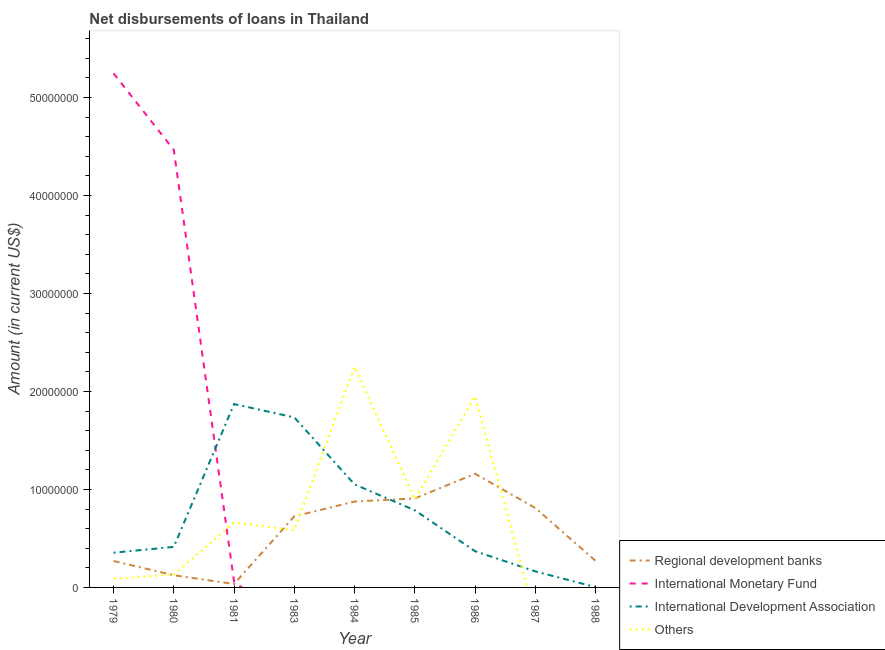Does the line corresponding to amount of loan disimbursed by regional development banks intersect with the line corresponding to amount of loan disimbursed by other organisations?
Give a very brief answer. Yes. What is the amount of loan disimbursed by international monetary fund in 1988?
Your answer should be compact. 0. Across all years, what is the maximum amount of loan disimbursed by international monetary fund?
Give a very brief answer. 5.25e+07. Across all years, what is the minimum amount of loan disimbursed by international development association?
Your response must be concise. 3.50e+04. What is the total amount of loan disimbursed by international monetary fund in the graph?
Your answer should be very brief. 9.77e+07. What is the difference between the amount of loan disimbursed by other organisations in 1979 and that in 1981?
Make the answer very short. -5.74e+06. What is the difference between the amount of loan disimbursed by regional development banks in 1980 and the amount of loan disimbursed by other organisations in 1986?
Offer a very short reply. -1.83e+07. What is the average amount of loan disimbursed by international monetary fund per year?
Your response must be concise. 1.09e+07. In the year 1979, what is the difference between the amount of loan disimbursed by international development association and amount of loan disimbursed by international monetary fund?
Your answer should be very brief. -4.89e+07. What is the ratio of the amount of loan disimbursed by other organisations in 1980 to that in 1983?
Ensure brevity in your answer.  0.23. Is the amount of loan disimbursed by international development association in 1980 less than that in 1981?
Provide a short and direct response. Yes. What is the difference between the highest and the second highest amount of loan disimbursed by regional development banks?
Offer a terse response. 2.52e+06. What is the difference between the highest and the lowest amount of loan disimbursed by international development association?
Your response must be concise. 1.87e+07. In how many years, is the amount of loan disimbursed by regional development banks greater than the average amount of loan disimbursed by regional development banks taken over all years?
Keep it short and to the point. 5. Is the sum of the amount of loan disimbursed by international development association in 1981 and 1986 greater than the maximum amount of loan disimbursed by international monetary fund across all years?
Your answer should be very brief. No. Is it the case that in every year, the sum of the amount of loan disimbursed by international development association and amount of loan disimbursed by international monetary fund is greater than the sum of amount of loan disimbursed by other organisations and amount of loan disimbursed by regional development banks?
Make the answer very short. No. Does the amount of loan disimbursed by other organisations monotonically increase over the years?
Provide a short and direct response. No. Is the amount of loan disimbursed by international monetary fund strictly greater than the amount of loan disimbursed by other organisations over the years?
Your response must be concise. No. Is the amount of loan disimbursed by international monetary fund strictly less than the amount of loan disimbursed by international development association over the years?
Your response must be concise. No. How many lines are there?
Your answer should be compact. 4. How many years are there in the graph?
Give a very brief answer. 9. Are the values on the major ticks of Y-axis written in scientific E-notation?
Your answer should be very brief. No. Where does the legend appear in the graph?
Make the answer very short. Bottom right. How many legend labels are there?
Offer a terse response. 4. How are the legend labels stacked?
Your answer should be very brief. Vertical. What is the title of the graph?
Offer a terse response. Net disbursements of loans in Thailand. What is the label or title of the X-axis?
Your response must be concise. Year. What is the Amount (in current US$) in Regional development banks in 1979?
Provide a short and direct response. 2.70e+06. What is the Amount (in current US$) of International Monetary Fund in 1979?
Give a very brief answer. 5.25e+07. What is the Amount (in current US$) of International Development Association in 1979?
Give a very brief answer. 3.54e+06. What is the Amount (in current US$) in Others in 1979?
Offer a very short reply. 8.80e+05. What is the Amount (in current US$) of Regional development banks in 1980?
Your response must be concise. 1.24e+06. What is the Amount (in current US$) of International Monetary Fund in 1980?
Offer a very short reply. 4.46e+07. What is the Amount (in current US$) in International Development Association in 1980?
Ensure brevity in your answer.  4.14e+06. What is the Amount (in current US$) of Others in 1980?
Provide a succinct answer. 1.32e+06. What is the Amount (in current US$) in Regional development banks in 1981?
Your answer should be compact. 3.49e+05. What is the Amount (in current US$) of International Monetary Fund in 1981?
Offer a terse response. 5.97e+05. What is the Amount (in current US$) in International Development Association in 1981?
Offer a very short reply. 1.87e+07. What is the Amount (in current US$) in Others in 1981?
Ensure brevity in your answer.  6.62e+06. What is the Amount (in current US$) in Regional development banks in 1983?
Provide a short and direct response. 7.25e+06. What is the Amount (in current US$) of International Development Association in 1983?
Give a very brief answer. 1.73e+07. What is the Amount (in current US$) of Others in 1983?
Give a very brief answer. 5.84e+06. What is the Amount (in current US$) of Regional development banks in 1984?
Your answer should be very brief. 8.76e+06. What is the Amount (in current US$) in International Monetary Fund in 1984?
Your answer should be compact. 0. What is the Amount (in current US$) of International Development Association in 1984?
Make the answer very short. 1.05e+07. What is the Amount (in current US$) in Others in 1984?
Keep it short and to the point. 2.25e+07. What is the Amount (in current US$) in Regional development banks in 1985?
Ensure brevity in your answer.  9.08e+06. What is the Amount (in current US$) in International Development Association in 1985?
Make the answer very short. 7.87e+06. What is the Amount (in current US$) of Others in 1985?
Your answer should be very brief. 8.98e+06. What is the Amount (in current US$) of Regional development banks in 1986?
Offer a very short reply. 1.16e+07. What is the Amount (in current US$) in International Development Association in 1986?
Your answer should be compact. 3.70e+06. What is the Amount (in current US$) of Others in 1986?
Your response must be concise. 1.95e+07. What is the Amount (in current US$) in Regional development banks in 1987?
Make the answer very short. 8.10e+06. What is the Amount (in current US$) in International Development Association in 1987?
Make the answer very short. 1.64e+06. What is the Amount (in current US$) of Others in 1987?
Make the answer very short. 0. What is the Amount (in current US$) of Regional development banks in 1988?
Provide a succinct answer. 2.71e+06. What is the Amount (in current US$) in International Development Association in 1988?
Your response must be concise. 3.50e+04. Across all years, what is the maximum Amount (in current US$) in Regional development banks?
Give a very brief answer. 1.16e+07. Across all years, what is the maximum Amount (in current US$) in International Monetary Fund?
Offer a terse response. 5.25e+07. Across all years, what is the maximum Amount (in current US$) of International Development Association?
Offer a terse response. 1.87e+07. Across all years, what is the maximum Amount (in current US$) in Others?
Give a very brief answer. 2.25e+07. Across all years, what is the minimum Amount (in current US$) in Regional development banks?
Offer a terse response. 3.49e+05. Across all years, what is the minimum Amount (in current US$) in International Monetary Fund?
Provide a succinct answer. 0. Across all years, what is the minimum Amount (in current US$) of International Development Association?
Give a very brief answer. 3.50e+04. What is the total Amount (in current US$) in Regional development banks in the graph?
Offer a very short reply. 5.18e+07. What is the total Amount (in current US$) in International Monetary Fund in the graph?
Your answer should be compact. 9.77e+07. What is the total Amount (in current US$) of International Development Association in the graph?
Give a very brief answer. 6.75e+07. What is the total Amount (in current US$) in Others in the graph?
Offer a very short reply. 6.57e+07. What is the difference between the Amount (in current US$) in Regional development banks in 1979 and that in 1980?
Provide a succinct answer. 1.46e+06. What is the difference between the Amount (in current US$) of International Monetary Fund in 1979 and that in 1980?
Your answer should be very brief. 7.81e+06. What is the difference between the Amount (in current US$) in International Development Association in 1979 and that in 1980?
Offer a terse response. -5.97e+05. What is the difference between the Amount (in current US$) in Others in 1979 and that in 1980?
Offer a terse response. -4.36e+05. What is the difference between the Amount (in current US$) of Regional development banks in 1979 and that in 1981?
Offer a terse response. 2.35e+06. What is the difference between the Amount (in current US$) in International Monetary Fund in 1979 and that in 1981?
Your response must be concise. 5.19e+07. What is the difference between the Amount (in current US$) of International Development Association in 1979 and that in 1981?
Ensure brevity in your answer.  -1.52e+07. What is the difference between the Amount (in current US$) in Others in 1979 and that in 1981?
Give a very brief answer. -5.74e+06. What is the difference between the Amount (in current US$) in Regional development banks in 1979 and that in 1983?
Make the answer very short. -4.56e+06. What is the difference between the Amount (in current US$) in International Development Association in 1979 and that in 1983?
Make the answer very short. -1.38e+07. What is the difference between the Amount (in current US$) of Others in 1979 and that in 1983?
Offer a very short reply. -4.96e+06. What is the difference between the Amount (in current US$) of Regional development banks in 1979 and that in 1984?
Offer a terse response. -6.07e+06. What is the difference between the Amount (in current US$) in International Development Association in 1979 and that in 1984?
Give a very brief answer. -6.97e+06. What is the difference between the Amount (in current US$) of Others in 1979 and that in 1984?
Your answer should be very brief. -2.16e+07. What is the difference between the Amount (in current US$) of Regional development banks in 1979 and that in 1985?
Give a very brief answer. -6.38e+06. What is the difference between the Amount (in current US$) in International Development Association in 1979 and that in 1985?
Your answer should be very brief. -4.33e+06. What is the difference between the Amount (in current US$) in Others in 1979 and that in 1985?
Make the answer very short. -8.10e+06. What is the difference between the Amount (in current US$) in Regional development banks in 1979 and that in 1986?
Your answer should be compact. -8.90e+06. What is the difference between the Amount (in current US$) of International Development Association in 1979 and that in 1986?
Ensure brevity in your answer.  -1.55e+05. What is the difference between the Amount (in current US$) of Others in 1979 and that in 1986?
Your response must be concise. -1.86e+07. What is the difference between the Amount (in current US$) of Regional development banks in 1979 and that in 1987?
Give a very brief answer. -5.41e+06. What is the difference between the Amount (in current US$) of International Development Association in 1979 and that in 1987?
Keep it short and to the point. 1.90e+06. What is the difference between the Amount (in current US$) of Regional development banks in 1979 and that in 1988?
Your answer should be very brief. -1.30e+04. What is the difference between the Amount (in current US$) in International Development Association in 1979 and that in 1988?
Your answer should be compact. 3.51e+06. What is the difference between the Amount (in current US$) in Regional development banks in 1980 and that in 1981?
Keep it short and to the point. 8.93e+05. What is the difference between the Amount (in current US$) in International Monetary Fund in 1980 and that in 1981?
Provide a succinct answer. 4.41e+07. What is the difference between the Amount (in current US$) of International Development Association in 1980 and that in 1981?
Offer a very short reply. -1.46e+07. What is the difference between the Amount (in current US$) in Others in 1980 and that in 1981?
Provide a short and direct response. -5.31e+06. What is the difference between the Amount (in current US$) of Regional development banks in 1980 and that in 1983?
Provide a succinct answer. -6.01e+06. What is the difference between the Amount (in current US$) in International Development Association in 1980 and that in 1983?
Give a very brief answer. -1.32e+07. What is the difference between the Amount (in current US$) in Others in 1980 and that in 1983?
Ensure brevity in your answer.  -4.53e+06. What is the difference between the Amount (in current US$) of Regional development banks in 1980 and that in 1984?
Provide a short and direct response. -7.52e+06. What is the difference between the Amount (in current US$) of International Development Association in 1980 and that in 1984?
Ensure brevity in your answer.  -6.37e+06. What is the difference between the Amount (in current US$) of Others in 1980 and that in 1984?
Keep it short and to the point. -2.12e+07. What is the difference between the Amount (in current US$) of Regional development banks in 1980 and that in 1985?
Your answer should be compact. -7.84e+06. What is the difference between the Amount (in current US$) of International Development Association in 1980 and that in 1985?
Provide a succinct answer. -3.74e+06. What is the difference between the Amount (in current US$) in Others in 1980 and that in 1985?
Offer a very short reply. -7.67e+06. What is the difference between the Amount (in current US$) of Regional development banks in 1980 and that in 1986?
Offer a very short reply. -1.04e+07. What is the difference between the Amount (in current US$) of International Development Association in 1980 and that in 1986?
Ensure brevity in your answer.  4.42e+05. What is the difference between the Amount (in current US$) in Others in 1980 and that in 1986?
Your answer should be compact. -1.82e+07. What is the difference between the Amount (in current US$) in Regional development banks in 1980 and that in 1987?
Keep it short and to the point. -6.86e+06. What is the difference between the Amount (in current US$) in International Development Association in 1980 and that in 1987?
Provide a short and direct response. 2.50e+06. What is the difference between the Amount (in current US$) in Regional development banks in 1980 and that in 1988?
Offer a very short reply. -1.47e+06. What is the difference between the Amount (in current US$) in International Development Association in 1980 and that in 1988?
Give a very brief answer. 4.10e+06. What is the difference between the Amount (in current US$) in Regional development banks in 1981 and that in 1983?
Ensure brevity in your answer.  -6.90e+06. What is the difference between the Amount (in current US$) in International Development Association in 1981 and that in 1983?
Keep it short and to the point. 1.37e+06. What is the difference between the Amount (in current US$) in Others in 1981 and that in 1983?
Ensure brevity in your answer.  7.80e+05. What is the difference between the Amount (in current US$) in Regional development banks in 1981 and that in 1984?
Keep it short and to the point. -8.42e+06. What is the difference between the Amount (in current US$) in International Development Association in 1981 and that in 1984?
Offer a terse response. 8.20e+06. What is the difference between the Amount (in current US$) in Others in 1981 and that in 1984?
Your response must be concise. -1.59e+07. What is the difference between the Amount (in current US$) in Regional development banks in 1981 and that in 1985?
Provide a succinct answer. -8.73e+06. What is the difference between the Amount (in current US$) of International Development Association in 1981 and that in 1985?
Provide a succinct answer. 1.08e+07. What is the difference between the Amount (in current US$) in Others in 1981 and that in 1985?
Ensure brevity in your answer.  -2.36e+06. What is the difference between the Amount (in current US$) in Regional development banks in 1981 and that in 1986?
Your answer should be very brief. -1.13e+07. What is the difference between the Amount (in current US$) of International Development Association in 1981 and that in 1986?
Offer a very short reply. 1.50e+07. What is the difference between the Amount (in current US$) in Others in 1981 and that in 1986?
Your answer should be very brief. -1.29e+07. What is the difference between the Amount (in current US$) in Regional development banks in 1981 and that in 1987?
Offer a terse response. -7.76e+06. What is the difference between the Amount (in current US$) in International Development Association in 1981 and that in 1987?
Provide a short and direct response. 1.71e+07. What is the difference between the Amount (in current US$) in Regional development banks in 1981 and that in 1988?
Make the answer very short. -2.36e+06. What is the difference between the Amount (in current US$) in International Development Association in 1981 and that in 1988?
Provide a succinct answer. 1.87e+07. What is the difference between the Amount (in current US$) in Regional development banks in 1983 and that in 1984?
Keep it short and to the point. -1.51e+06. What is the difference between the Amount (in current US$) in International Development Association in 1983 and that in 1984?
Make the answer very short. 6.84e+06. What is the difference between the Amount (in current US$) of Others in 1983 and that in 1984?
Provide a short and direct response. -1.67e+07. What is the difference between the Amount (in current US$) in Regional development banks in 1983 and that in 1985?
Give a very brief answer. -1.83e+06. What is the difference between the Amount (in current US$) in International Development Association in 1983 and that in 1985?
Offer a terse response. 9.48e+06. What is the difference between the Amount (in current US$) of Others in 1983 and that in 1985?
Provide a succinct answer. -3.14e+06. What is the difference between the Amount (in current US$) of Regional development banks in 1983 and that in 1986?
Your response must be concise. -4.35e+06. What is the difference between the Amount (in current US$) of International Development Association in 1983 and that in 1986?
Your answer should be compact. 1.37e+07. What is the difference between the Amount (in current US$) of Others in 1983 and that in 1986?
Keep it short and to the point. -1.37e+07. What is the difference between the Amount (in current US$) in Regional development banks in 1983 and that in 1987?
Provide a succinct answer. -8.52e+05. What is the difference between the Amount (in current US$) of International Development Association in 1983 and that in 1987?
Your response must be concise. 1.57e+07. What is the difference between the Amount (in current US$) of Regional development banks in 1983 and that in 1988?
Offer a terse response. 4.54e+06. What is the difference between the Amount (in current US$) of International Development Association in 1983 and that in 1988?
Your answer should be very brief. 1.73e+07. What is the difference between the Amount (in current US$) in Regional development banks in 1984 and that in 1985?
Give a very brief answer. -3.15e+05. What is the difference between the Amount (in current US$) in International Development Association in 1984 and that in 1985?
Make the answer very short. 2.64e+06. What is the difference between the Amount (in current US$) of Others in 1984 and that in 1985?
Your answer should be very brief. 1.35e+07. What is the difference between the Amount (in current US$) in Regional development banks in 1984 and that in 1986?
Make the answer very short. -2.84e+06. What is the difference between the Amount (in current US$) of International Development Association in 1984 and that in 1986?
Your answer should be very brief. 6.82e+06. What is the difference between the Amount (in current US$) of Others in 1984 and that in 1986?
Provide a short and direct response. 3.02e+06. What is the difference between the Amount (in current US$) in Regional development banks in 1984 and that in 1987?
Make the answer very short. 6.59e+05. What is the difference between the Amount (in current US$) in International Development Association in 1984 and that in 1987?
Offer a very short reply. 8.88e+06. What is the difference between the Amount (in current US$) of Regional development banks in 1984 and that in 1988?
Offer a terse response. 6.05e+06. What is the difference between the Amount (in current US$) in International Development Association in 1984 and that in 1988?
Provide a short and direct response. 1.05e+07. What is the difference between the Amount (in current US$) of Regional development banks in 1985 and that in 1986?
Your answer should be very brief. -2.52e+06. What is the difference between the Amount (in current US$) in International Development Association in 1985 and that in 1986?
Keep it short and to the point. 4.18e+06. What is the difference between the Amount (in current US$) of Others in 1985 and that in 1986?
Make the answer very short. -1.05e+07. What is the difference between the Amount (in current US$) in Regional development banks in 1985 and that in 1987?
Provide a short and direct response. 9.74e+05. What is the difference between the Amount (in current US$) of International Development Association in 1985 and that in 1987?
Your answer should be very brief. 6.24e+06. What is the difference between the Amount (in current US$) of Regional development banks in 1985 and that in 1988?
Ensure brevity in your answer.  6.37e+06. What is the difference between the Amount (in current US$) of International Development Association in 1985 and that in 1988?
Your answer should be compact. 7.84e+06. What is the difference between the Amount (in current US$) of Regional development banks in 1986 and that in 1987?
Offer a terse response. 3.50e+06. What is the difference between the Amount (in current US$) in International Development Association in 1986 and that in 1987?
Give a very brief answer. 2.06e+06. What is the difference between the Amount (in current US$) of Regional development banks in 1986 and that in 1988?
Offer a very short reply. 8.89e+06. What is the difference between the Amount (in current US$) of International Development Association in 1986 and that in 1988?
Your answer should be compact. 3.66e+06. What is the difference between the Amount (in current US$) of Regional development banks in 1987 and that in 1988?
Keep it short and to the point. 5.39e+06. What is the difference between the Amount (in current US$) of International Development Association in 1987 and that in 1988?
Provide a short and direct response. 1.60e+06. What is the difference between the Amount (in current US$) of Regional development banks in 1979 and the Amount (in current US$) of International Monetary Fund in 1980?
Make the answer very short. -4.20e+07. What is the difference between the Amount (in current US$) of Regional development banks in 1979 and the Amount (in current US$) of International Development Association in 1980?
Your answer should be compact. -1.44e+06. What is the difference between the Amount (in current US$) of Regional development banks in 1979 and the Amount (in current US$) of Others in 1980?
Your answer should be compact. 1.38e+06. What is the difference between the Amount (in current US$) in International Monetary Fund in 1979 and the Amount (in current US$) in International Development Association in 1980?
Give a very brief answer. 4.83e+07. What is the difference between the Amount (in current US$) in International Monetary Fund in 1979 and the Amount (in current US$) in Others in 1980?
Provide a succinct answer. 5.11e+07. What is the difference between the Amount (in current US$) of International Development Association in 1979 and the Amount (in current US$) of Others in 1980?
Offer a terse response. 2.23e+06. What is the difference between the Amount (in current US$) in Regional development banks in 1979 and the Amount (in current US$) in International Monetary Fund in 1981?
Your answer should be very brief. 2.10e+06. What is the difference between the Amount (in current US$) in Regional development banks in 1979 and the Amount (in current US$) in International Development Association in 1981?
Your answer should be compact. -1.60e+07. What is the difference between the Amount (in current US$) in Regional development banks in 1979 and the Amount (in current US$) in Others in 1981?
Your answer should be compact. -3.92e+06. What is the difference between the Amount (in current US$) of International Monetary Fund in 1979 and the Amount (in current US$) of International Development Association in 1981?
Give a very brief answer. 3.37e+07. What is the difference between the Amount (in current US$) of International Monetary Fund in 1979 and the Amount (in current US$) of Others in 1981?
Offer a very short reply. 4.58e+07. What is the difference between the Amount (in current US$) in International Development Association in 1979 and the Amount (in current US$) in Others in 1981?
Your answer should be compact. -3.08e+06. What is the difference between the Amount (in current US$) of Regional development banks in 1979 and the Amount (in current US$) of International Development Association in 1983?
Your response must be concise. -1.47e+07. What is the difference between the Amount (in current US$) of Regional development banks in 1979 and the Amount (in current US$) of Others in 1983?
Ensure brevity in your answer.  -3.14e+06. What is the difference between the Amount (in current US$) of International Monetary Fund in 1979 and the Amount (in current US$) of International Development Association in 1983?
Your answer should be very brief. 3.51e+07. What is the difference between the Amount (in current US$) of International Monetary Fund in 1979 and the Amount (in current US$) of Others in 1983?
Your answer should be compact. 4.66e+07. What is the difference between the Amount (in current US$) of International Development Association in 1979 and the Amount (in current US$) of Others in 1983?
Make the answer very short. -2.30e+06. What is the difference between the Amount (in current US$) of Regional development banks in 1979 and the Amount (in current US$) of International Development Association in 1984?
Offer a terse response. -7.81e+06. What is the difference between the Amount (in current US$) of Regional development banks in 1979 and the Amount (in current US$) of Others in 1984?
Make the answer very short. -1.98e+07. What is the difference between the Amount (in current US$) in International Monetary Fund in 1979 and the Amount (in current US$) in International Development Association in 1984?
Keep it short and to the point. 4.19e+07. What is the difference between the Amount (in current US$) of International Monetary Fund in 1979 and the Amount (in current US$) of Others in 1984?
Offer a terse response. 2.99e+07. What is the difference between the Amount (in current US$) in International Development Association in 1979 and the Amount (in current US$) in Others in 1984?
Give a very brief answer. -1.90e+07. What is the difference between the Amount (in current US$) of Regional development banks in 1979 and the Amount (in current US$) of International Development Association in 1985?
Your response must be concise. -5.18e+06. What is the difference between the Amount (in current US$) in Regional development banks in 1979 and the Amount (in current US$) in Others in 1985?
Provide a succinct answer. -6.29e+06. What is the difference between the Amount (in current US$) of International Monetary Fund in 1979 and the Amount (in current US$) of International Development Association in 1985?
Offer a very short reply. 4.46e+07. What is the difference between the Amount (in current US$) of International Monetary Fund in 1979 and the Amount (in current US$) of Others in 1985?
Your answer should be very brief. 4.35e+07. What is the difference between the Amount (in current US$) of International Development Association in 1979 and the Amount (in current US$) of Others in 1985?
Ensure brevity in your answer.  -5.44e+06. What is the difference between the Amount (in current US$) of Regional development banks in 1979 and the Amount (in current US$) of International Development Association in 1986?
Your answer should be very brief. -9.99e+05. What is the difference between the Amount (in current US$) of Regional development banks in 1979 and the Amount (in current US$) of Others in 1986?
Keep it short and to the point. -1.68e+07. What is the difference between the Amount (in current US$) in International Monetary Fund in 1979 and the Amount (in current US$) in International Development Association in 1986?
Offer a terse response. 4.88e+07. What is the difference between the Amount (in current US$) in International Monetary Fund in 1979 and the Amount (in current US$) in Others in 1986?
Your answer should be compact. 3.30e+07. What is the difference between the Amount (in current US$) of International Development Association in 1979 and the Amount (in current US$) of Others in 1986?
Offer a very short reply. -1.60e+07. What is the difference between the Amount (in current US$) of Regional development banks in 1979 and the Amount (in current US$) of International Development Association in 1987?
Your answer should be very brief. 1.06e+06. What is the difference between the Amount (in current US$) in International Monetary Fund in 1979 and the Amount (in current US$) in International Development Association in 1987?
Your answer should be compact. 5.08e+07. What is the difference between the Amount (in current US$) of Regional development banks in 1979 and the Amount (in current US$) of International Development Association in 1988?
Keep it short and to the point. 2.66e+06. What is the difference between the Amount (in current US$) in International Monetary Fund in 1979 and the Amount (in current US$) in International Development Association in 1988?
Offer a terse response. 5.24e+07. What is the difference between the Amount (in current US$) in Regional development banks in 1980 and the Amount (in current US$) in International Monetary Fund in 1981?
Provide a succinct answer. 6.45e+05. What is the difference between the Amount (in current US$) in Regional development banks in 1980 and the Amount (in current US$) in International Development Association in 1981?
Offer a terse response. -1.75e+07. What is the difference between the Amount (in current US$) of Regional development banks in 1980 and the Amount (in current US$) of Others in 1981?
Keep it short and to the point. -5.38e+06. What is the difference between the Amount (in current US$) in International Monetary Fund in 1980 and the Amount (in current US$) in International Development Association in 1981?
Provide a succinct answer. 2.59e+07. What is the difference between the Amount (in current US$) in International Monetary Fund in 1980 and the Amount (in current US$) in Others in 1981?
Provide a short and direct response. 3.80e+07. What is the difference between the Amount (in current US$) in International Development Association in 1980 and the Amount (in current US$) in Others in 1981?
Provide a short and direct response. -2.48e+06. What is the difference between the Amount (in current US$) of Regional development banks in 1980 and the Amount (in current US$) of International Development Association in 1983?
Provide a succinct answer. -1.61e+07. What is the difference between the Amount (in current US$) in Regional development banks in 1980 and the Amount (in current US$) in Others in 1983?
Make the answer very short. -4.60e+06. What is the difference between the Amount (in current US$) in International Monetary Fund in 1980 and the Amount (in current US$) in International Development Association in 1983?
Your answer should be very brief. 2.73e+07. What is the difference between the Amount (in current US$) of International Monetary Fund in 1980 and the Amount (in current US$) of Others in 1983?
Keep it short and to the point. 3.88e+07. What is the difference between the Amount (in current US$) of International Development Association in 1980 and the Amount (in current US$) of Others in 1983?
Provide a succinct answer. -1.70e+06. What is the difference between the Amount (in current US$) in Regional development banks in 1980 and the Amount (in current US$) in International Development Association in 1984?
Offer a very short reply. -9.27e+06. What is the difference between the Amount (in current US$) in Regional development banks in 1980 and the Amount (in current US$) in Others in 1984?
Provide a short and direct response. -2.13e+07. What is the difference between the Amount (in current US$) in International Monetary Fund in 1980 and the Amount (in current US$) in International Development Association in 1984?
Your answer should be very brief. 3.41e+07. What is the difference between the Amount (in current US$) in International Monetary Fund in 1980 and the Amount (in current US$) in Others in 1984?
Provide a succinct answer. 2.21e+07. What is the difference between the Amount (in current US$) of International Development Association in 1980 and the Amount (in current US$) of Others in 1984?
Your answer should be compact. -1.84e+07. What is the difference between the Amount (in current US$) in Regional development banks in 1980 and the Amount (in current US$) in International Development Association in 1985?
Your answer should be very brief. -6.63e+06. What is the difference between the Amount (in current US$) of Regional development banks in 1980 and the Amount (in current US$) of Others in 1985?
Offer a terse response. -7.74e+06. What is the difference between the Amount (in current US$) in International Monetary Fund in 1980 and the Amount (in current US$) in International Development Association in 1985?
Provide a short and direct response. 3.68e+07. What is the difference between the Amount (in current US$) of International Monetary Fund in 1980 and the Amount (in current US$) of Others in 1985?
Keep it short and to the point. 3.57e+07. What is the difference between the Amount (in current US$) in International Development Association in 1980 and the Amount (in current US$) in Others in 1985?
Keep it short and to the point. -4.84e+06. What is the difference between the Amount (in current US$) of Regional development banks in 1980 and the Amount (in current US$) of International Development Association in 1986?
Provide a short and direct response. -2.46e+06. What is the difference between the Amount (in current US$) in Regional development banks in 1980 and the Amount (in current US$) in Others in 1986?
Offer a very short reply. -1.83e+07. What is the difference between the Amount (in current US$) in International Monetary Fund in 1980 and the Amount (in current US$) in International Development Association in 1986?
Keep it short and to the point. 4.10e+07. What is the difference between the Amount (in current US$) of International Monetary Fund in 1980 and the Amount (in current US$) of Others in 1986?
Give a very brief answer. 2.51e+07. What is the difference between the Amount (in current US$) in International Development Association in 1980 and the Amount (in current US$) in Others in 1986?
Keep it short and to the point. -1.54e+07. What is the difference between the Amount (in current US$) of Regional development banks in 1980 and the Amount (in current US$) of International Development Association in 1987?
Offer a terse response. -3.95e+05. What is the difference between the Amount (in current US$) of International Monetary Fund in 1980 and the Amount (in current US$) of International Development Association in 1987?
Provide a succinct answer. 4.30e+07. What is the difference between the Amount (in current US$) in Regional development banks in 1980 and the Amount (in current US$) in International Development Association in 1988?
Give a very brief answer. 1.21e+06. What is the difference between the Amount (in current US$) of International Monetary Fund in 1980 and the Amount (in current US$) of International Development Association in 1988?
Offer a terse response. 4.46e+07. What is the difference between the Amount (in current US$) of Regional development banks in 1981 and the Amount (in current US$) of International Development Association in 1983?
Offer a very short reply. -1.70e+07. What is the difference between the Amount (in current US$) of Regional development banks in 1981 and the Amount (in current US$) of Others in 1983?
Provide a short and direct response. -5.49e+06. What is the difference between the Amount (in current US$) in International Monetary Fund in 1981 and the Amount (in current US$) in International Development Association in 1983?
Provide a short and direct response. -1.68e+07. What is the difference between the Amount (in current US$) of International Monetary Fund in 1981 and the Amount (in current US$) of Others in 1983?
Keep it short and to the point. -5.25e+06. What is the difference between the Amount (in current US$) of International Development Association in 1981 and the Amount (in current US$) of Others in 1983?
Keep it short and to the point. 1.29e+07. What is the difference between the Amount (in current US$) of Regional development banks in 1981 and the Amount (in current US$) of International Development Association in 1984?
Your answer should be compact. -1.02e+07. What is the difference between the Amount (in current US$) of Regional development banks in 1981 and the Amount (in current US$) of Others in 1984?
Provide a short and direct response. -2.22e+07. What is the difference between the Amount (in current US$) in International Monetary Fund in 1981 and the Amount (in current US$) in International Development Association in 1984?
Ensure brevity in your answer.  -9.92e+06. What is the difference between the Amount (in current US$) of International Monetary Fund in 1981 and the Amount (in current US$) of Others in 1984?
Give a very brief answer. -2.19e+07. What is the difference between the Amount (in current US$) in International Development Association in 1981 and the Amount (in current US$) in Others in 1984?
Give a very brief answer. -3.81e+06. What is the difference between the Amount (in current US$) in Regional development banks in 1981 and the Amount (in current US$) in International Development Association in 1985?
Your answer should be compact. -7.52e+06. What is the difference between the Amount (in current US$) in Regional development banks in 1981 and the Amount (in current US$) in Others in 1985?
Your response must be concise. -8.64e+06. What is the difference between the Amount (in current US$) in International Monetary Fund in 1981 and the Amount (in current US$) in International Development Association in 1985?
Make the answer very short. -7.28e+06. What is the difference between the Amount (in current US$) in International Monetary Fund in 1981 and the Amount (in current US$) in Others in 1985?
Provide a succinct answer. -8.39e+06. What is the difference between the Amount (in current US$) in International Development Association in 1981 and the Amount (in current US$) in Others in 1985?
Keep it short and to the point. 9.73e+06. What is the difference between the Amount (in current US$) of Regional development banks in 1981 and the Amount (in current US$) of International Development Association in 1986?
Your response must be concise. -3.35e+06. What is the difference between the Amount (in current US$) in Regional development banks in 1981 and the Amount (in current US$) in Others in 1986?
Make the answer very short. -1.92e+07. What is the difference between the Amount (in current US$) in International Monetary Fund in 1981 and the Amount (in current US$) in International Development Association in 1986?
Provide a succinct answer. -3.10e+06. What is the difference between the Amount (in current US$) of International Monetary Fund in 1981 and the Amount (in current US$) of Others in 1986?
Give a very brief answer. -1.89e+07. What is the difference between the Amount (in current US$) of International Development Association in 1981 and the Amount (in current US$) of Others in 1986?
Your response must be concise. -7.89e+05. What is the difference between the Amount (in current US$) in Regional development banks in 1981 and the Amount (in current US$) in International Development Association in 1987?
Your response must be concise. -1.29e+06. What is the difference between the Amount (in current US$) of International Monetary Fund in 1981 and the Amount (in current US$) of International Development Association in 1987?
Ensure brevity in your answer.  -1.04e+06. What is the difference between the Amount (in current US$) of Regional development banks in 1981 and the Amount (in current US$) of International Development Association in 1988?
Offer a terse response. 3.14e+05. What is the difference between the Amount (in current US$) in International Monetary Fund in 1981 and the Amount (in current US$) in International Development Association in 1988?
Your response must be concise. 5.62e+05. What is the difference between the Amount (in current US$) in Regional development banks in 1983 and the Amount (in current US$) in International Development Association in 1984?
Give a very brief answer. -3.26e+06. What is the difference between the Amount (in current US$) of Regional development banks in 1983 and the Amount (in current US$) of Others in 1984?
Your answer should be compact. -1.53e+07. What is the difference between the Amount (in current US$) in International Development Association in 1983 and the Amount (in current US$) in Others in 1984?
Offer a very short reply. -5.18e+06. What is the difference between the Amount (in current US$) in Regional development banks in 1983 and the Amount (in current US$) in International Development Association in 1985?
Make the answer very short. -6.21e+05. What is the difference between the Amount (in current US$) in Regional development banks in 1983 and the Amount (in current US$) in Others in 1985?
Ensure brevity in your answer.  -1.73e+06. What is the difference between the Amount (in current US$) in International Development Association in 1983 and the Amount (in current US$) in Others in 1985?
Your answer should be very brief. 8.36e+06. What is the difference between the Amount (in current US$) in Regional development banks in 1983 and the Amount (in current US$) in International Development Association in 1986?
Provide a succinct answer. 3.56e+06. What is the difference between the Amount (in current US$) of Regional development banks in 1983 and the Amount (in current US$) of Others in 1986?
Your response must be concise. -1.23e+07. What is the difference between the Amount (in current US$) in International Development Association in 1983 and the Amount (in current US$) in Others in 1986?
Keep it short and to the point. -2.16e+06. What is the difference between the Amount (in current US$) in Regional development banks in 1983 and the Amount (in current US$) in International Development Association in 1987?
Your answer should be compact. 5.62e+06. What is the difference between the Amount (in current US$) in Regional development banks in 1983 and the Amount (in current US$) in International Development Association in 1988?
Give a very brief answer. 7.22e+06. What is the difference between the Amount (in current US$) in Regional development banks in 1984 and the Amount (in current US$) in International Development Association in 1985?
Provide a succinct answer. 8.90e+05. What is the difference between the Amount (in current US$) in Regional development banks in 1984 and the Amount (in current US$) in Others in 1985?
Offer a very short reply. -2.20e+05. What is the difference between the Amount (in current US$) of International Development Association in 1984 and the Amount (in current US$) of Others in 1985?
Your response must be concise. 1.53e+06. What is the difference between the Amount (in current US$) in Regional development banks in 1984 and the Amount (in current US$) in International Development Association in 1986?
Offer a very short reply. 5.07e+06. What is the difference between the Amount (in current US$) in Regional development banks in 1984 and the Amount (in current US$) in Others in 1986?
Provide a short and direct response. -1.07e+07. What is the difference between the Amount (in current US$) in International Development Association in 1984 and the Amount (in current US$) in Others in 1986?
Your answer should be compact. -8.99e+06. What is the difference between the Amount (in current US$) of Regional development banks in 1984 and the Amount (in current US$) of International Development Association in 1987?
Make the answer very short. 7.13e+06. What is the difference between the Amount (in current US$) in Regional development banks in 1984 and the Amount (in current US$) in International Development Association in 1988?
Your answer should be compact. 8.73e+06. What is the difference between the Amount (in current US$) in Regional development banks in 1985 and the Amount (in current US$) in International Development Association in 1986?
Offer a very short reply. 5.38e+06. What is the difference between the Amount (in current US$) of Regional development banks in 1985 and the Amount (in current US$) of Others in 1986?
Provide a succinct answer. -1.04e+07. What is the difference between the Amount (in current US$) in International Development Association in 1985 and the Amount (in current US$) in Others in 1986?
Your answer should be very brief. -1.16e+07. What is the difference between the Amount (in current US$) of Regional development banks in 1985 and the Amount (in current US$) of International Development Association in 1987?
Your answer should be very brief. 7.44e+06. What is the difference between the Amount (in current US$) of Regional development banks in 1985 and the Amount (in current US$) of International Development Association in 1988?
Your response must be concise. 9.04e+06. What is the difference between the Amount (in current US$) in Regional development banks in 1986 and the Amount (in current US$) in International Development Association in 1987?
Make the answer very short. 9.96e+06. What is the difference between the Amount (in current US$) of Regional development banks in 1986 and the Amount (in current US$) of International Development Association in 1988?
Your response must be concise. 1.16e+07. What is the difference between the Amount (in current US$) in Regional development banks in 1987 and the Amount (in current US$) in International Development Association in 1988?
Ensure brevity in your answer.  8.07e+06. What is the average Amount (in current US$) in Regional development banks per year?
Provide a short and direct response. 5.76e+06. What is the average Amount (in current US$) of International Monetary Fund per year?
Ensure brevity in your answer.  1.09e+07. What is the average Amount (in current US$) in International Development Association per year?
Give a very brief answer. 7.50e+06. What is the average Amount (in current US$) in Others per year?
Provide a short and direct response. 7.30e+06. In the year 1979, what is the difference between the Amount (in current US$) in Regional development banks and Amount (in current US$) in International Monetary Fund?
Your answer should be compact. -4.98e+07. In the year 1979, what is the difference between the Amount (in current US$) in Regional development banks and Amount (in current US$) in International Development Association?
Make the answer very short. -8.44e+05. In the year 1979, what is the difference between the Amount (in current US$) of Regional development banks and Amount (in current US$) of Others?
Provide a short and direct response. 1.82e+06. In the year 1979, what is the difference between the Amount (in current US$) in International Monetary Fund and Amount (in current US$) in International Development Association?
Offer a terse response. 4.89e+07. In the year 1979, what is the difference between the Amount (in current US$) in International Monetary Fund and Amount (in current US$) in Others?
Your response must be concise. 5.16e+07. In the year 1979, what is the difference between the Amount (in current US$) of International Development Association and Amount (in current US$) of Others?
Make the answer very short. 2.66e+06. In the year 1980, what is the difference between the Amount (in current US$) of Regional development banks and Amount (in current US$) of International Monetary Fund?
Keep it short and to the point. -4.34e+07. In the year 1980, what is the difference between the Amount (in current US$) of Regional development banks and Amount (in current US$) of International Development Association?
Your answer should be compact. -2.90e+06. In the year 1980, what is the difference between the Amount (in current US$) of Regional development banks and Amount (in current US$) of Others?
Provide a short and direct response. -7.40e+04. In the year 1980, what is the difference between the Amount (in current US$) of International Monetary Fund and Amount (in current US$) of International Development Association?
Provide a short and direct response. 4.05e+07. In the year 1980, what is the difference between the Amount (in current US$) in International Monetary Fund and Amount (in current US$) in Others?
Your answer should be compact. 4.33e+07. In the year 1980, what is the difference between the Amount (in current US$) of International Development Association and Amount (in current US$) of Others?
Provide a short and direct response. 2.82e+06. In the year 1981, what is the difference between the Amount (in current US$) of Regional development banks and Amount (in current US$) of International Monetary Fund?
Make the answer very short. -2.48e+05. In the year 1981, what is the difference between the Amount (in current US$) in Regional development banks and Amount (in current US$) in International Development Association?
Provide a short and direct response. -1.84e+07. In the year 1981, what is the difference between the Amount (in current US$) in Regional development banks and Amount (in current US$) in Others?
Keep it short and to the point. -6.27e+06. In the year 1981, what is the difference between the Amount (in current US$) in International Monetary Fund and Amount (in current US$) in International Development Association?
Make the answer very short. -1.81e+07. In the year 1981, what is the difference between the Amount (in current US$) in International Monetary Fund and Amount (in current US$) in Others?
Ensure brevity in your answer.  -6.03e+06. In the year 1981, what is the difference between the Amount (in current US$) of International Development Association and Amount (in current US$) of Others?
Your answer should be compact. 1.21e+07. In the year 1983, what is the difference between the Amount (in current US$) of Regional development banks and Amount (in current US$) of International Development Association?
Your answer should be compact. -1.01e+07. In the year 1983, what is the difference between the Amount (in current US$) in Regional development banks and Amount (in current US$) in Others?
Offer a very short reply. 1.41e+06. In the year 1983, what is the difference between the Amount (in current US$) in International Development Association and Amount (in current US$) in Others?
Provide a succinct answer. 1.15e+07. In the year 1984, what is the difference between the Amount (in current US$) of Regional development banks and Amount (in current US$) of International Development Association?
Provide a succinct answer. -1.75e+06. In the year 1984, what is the difference between the Amount (in current US$) of Regional development banks and Amount (in current US$) of Others?
Your answer should be very brief. -1.38e+07. In the year 1984, what is the difference between the Amount (in current US$) of International Development Association and Amount (in current US$) of Others?
Your response must be concise. -1.20e+07. In the year 1985, what is the difference between the Amount (in current US$) of Regional development banks and Amount (in current US$) of International Development Association?
Give a very brief answer. 1.20e+06. In the year 1985, what is the difference between the Amount (in current US$) of Regional development banks and Amount (in current US$) of Others?
Provide a succinct answer. 9.50e+04. In the year 1985, what is the difference between the Amount (in current US$) of International Development Association and Amount (in current US$) of Others?
Offer a very short reply. -1.11e+06. In the year 1986, what is the difference between the Amount (in current US$) of Regional development banks and Amount (in current US$) of International Development Association?
Give a very brief answer. 7.90e+06. In the year 1986, what is the difference between the Amount (in current US$) of Regional development banks and Amount (in current US$) of Others?
Ensure brevity in your answer.  -7.91e+06. In the year 1986, what is the difference between the Amount (in current US$) of International Development Association and Amount (in current US$) of Others?
Ensure brevity in your answer.  -1.58e+07. In the year 1987, what is the difference between the Amount (in current US$) of Regional development banks and Amount (in current US$) of International Development Association?
Offer a very short reply. 6.47e+06. In the year 1988, what is the difference between the Amount (in current US$) in Regional development banks and Amount (in current US$) in International Development Association?
Offer a terse response. 2.68e+06. What is the ratio of the Amount (in current US$) of Regional development banks in 1979 to that in 1980?
Your response must be concise. 2.17. What is the ratio of the Amount (in current US$) in International Monetary Fund in 1979 to that in 1980?
Provide a short and direct response. 1.17. What is the ratio of the Amount (in current US$) of International Development Association in 1979 to that in 1980?
Offer a very short reply. 0.86. What is the ratio of the Amount (in current US$) in Others in 1979 to that in 1980?
Your response must be concise. 0.67. What is the ratio of the Amount (in current US$) of Regional development banks in 1979 to that in 1981?
Keep it short and to the point. 7.73. What is the ratio of the Amount (in current US$) in International Monetary Fund in 1979 to that in 1981?
Keep it short and to the point. 87.87. What is the ratio of the Amount (in current US$) of International Development Association in 1979 to that in 1981?
Offer a very short reply. 0.19. What is the ratio of the Amount (in current US$) in Others in 1979 to that in 1981?
Give a very brief answer. 0.13. What is the ratio of the Amount (in current US$) of Regional development banks in 1979 to that in 1983?
Offer a terse response. 0.37. What is the ratio of the Amount (in current US$) in International Development Association in 1979 to that in 1983?
Your response must be concise. 0.2. What is the ratio of the Amount (in current US$) of Others in 1979 to that in 1983?
Your response must be concise. 0.15. What is the ratio of the Amount (in current US$) of Regional development banks in 1979 to that in 1984?
Ensure brevity in your answer.  0.31. What is the ratio of the Amount (in current US$) in International Development Association in 1979 to that in 1984?
Make the answer very short. 0.34. What is the ratio of the Amount (in current US$) in Others in 1979 to that in 1984?
Provide a short and direct response. 0.04. What is the ratio of the Amount (in current US$) of Regional development banks in 1979 to that in 1985?
Make the answer very short. 0.3. What is the ratio of the Amount (in current US$) of International Development Association in 1979 to that in 1985?
Offer a very short reply. 0.45. What is the ratio of the Amount (in current US$) of Others in 1979 to that in 1985?
Give a very brief answer. 0.1. What is the ratio of the Amount (in current US$) in Regional development banks in 1979 to that in 1986?
Make the answer very short. 0.23. What is the ratio of the Amount (in current US$) of International Development Association in 1979 to that in 1986?
Your response must be concise. 0.96. What is the ratio of the Amount (in current US$) of Others in 1979 to that in 1986?
Make the answer very short. 0.05. What is the ratio of the Amount (in current US$) of Regional development banks in 1979 to that in 1987?
Keep it short and to the point. 0.33. What is the ratio of the Amount (in current US$) of International Development Association in 1979 to that in 1987?
Provide a short and direct response. 2.16. What is the ratio of the Amount (in current US$) in Regional development banks in 1979 to that in 1988?
Your answer should be compact. 1. What is the ratio of the Amount (in current US$) in International Development Association in 1979 to that in 1988?
Your answer should be very brief. 101.2. What is the ratio of the Amount (in current US$) of Regional development banks in 1980 to that in 1981?
Make the answer very short. 3.56. What is the ratio of the Amount (in current US$) of International Monetary Fund in 1980 to that in 1981?
Provide a succinct answer. 74.79. What is the ratio of the Amount (in current US$) of International Development Association in 1980 to that in 1981?
Offer a very short reply. 0.22. What is the ratio of the Amount (in current US$) of Others in 1980 to that in 1981?
Make the answer very short. 0.2. What is the ratio of the Amount (in current US$) of Regional development banks in 1980 to that in 1983?
Give a very brief answer. 0.17. What is the ratio of the Amount (in current US$) in International Development Association in 1980 to that in 1983?
Keep it short and to the point. 0.24. What is the ratio of the Amount (in current US$) of Others in 1980 to that in 1983?
Ensure brevity in your answer.  0.23. What is the ratio of the Amount (in current US$) in Regional development banks in 1980 to that in 1984?
Your answer should be compact. 0.14. What is the ratio of the Amount (in current US$) of International Development Association in 1980 to that in 1984?
Your answer should be very brief. 0.39. What is the ratio of the Amount (in current US$) in Others in 1980 to that in 1984?
Make the answer very short. 0.06. What is the ratio of the Amount (in current US$) of Regional development banks in 1980 to that in 1985?
Offer a terse response. 0.14. What is the ratio of the Amount (in current US$) of International Development Association in 1980 to that in 1985?
Keep it short and to the point. 0.53. What is the ratio of the Amount (in current US$) in Others in 1980 to that in 1985?
Ensure brevity in your answer.  0.15. What is the ratio of the Amount (in current US$) of Regional development banks in 1980 to that in 1986?
Your response must be concise. 0.11. What is the ratio of the Amount (in current US$) of International Development Association in 1980 to that in 1986?
Offer a very short reply. 1.12. What is the ratio of the Amount (in current US$) of Others in 1980 to that in 1986?
Your answer should be very brief. 0.07. What is the ratio of the Amount (in current US$) of Regional development banks in 1980 to that in 1987?
Make the answer very short. 0.15. What is the ratio of the Amount (in current US$) of International Development Association in 1980 to that in 1987?
Your response must be concise. 2.53. What is the ratio of the Amount (in current US$) in Regional development banks in 1980 to that in 1988?
Give a very brief answer. 0.46. What is the ratio of the Amount (in current US$) in International Development Association in 1980 to that in 1988?
Keep it short and to the point. 118.26. What is the ratio of the Amount (in current US$) of Regional development banks in 1981 to that in 1983?
Provide a short and direct response. 0.05. What is the ratio of the Amount (in current US$) of International Development Association in 1981 to that in 1983?
Provide a short and direct response. 1.08. What is the ratio of the Amount (in current US$) of Others in 1981 to that in 1983?
Provide a succinct answer. 1.13. What is the ratio of the Amount (in current US$) in Regional development banks in 1981 to that in 1984?
Give a very brief answer. 0.04. What is the ratio of the Amount (in current US$) in International Development Association in 1981 to that in 1984?
Make the answer very short. 1.78. What is the ratio of the Amount (in current US$) of Others in 1981 to that in 1984?
Provide a short and direct response. 0.29. What is the ratio of the Amount (in current US$) of Regional development banks in 1981 to that in 1985?
Make the answer very short. 0.04. What is the ratio of the Amount (in current US$) of International Development Association in 1981 to that in 1985?
Make the answer very short. 2.38. What is the ratio of the Amount (in current US$) of Others in 1981 to that in 1985?
Offer a very short reply. 0.74. What is the ratio of the Amount (in current US$) in Regional development banks in 1981 to that in 1986?
Provide a short and direct response. 0.03. What is the ratio of the Amount (in current US$) of International Development Association in 1981 to that in 1986?
Make the answer very short. 5.06. What is the ratio of the Amount (in current US$) in Others in 1981 to that in 1986?
Make the answer very short. 0.34. What is the ratio of the Amount (in current US$) in Regional development banks in 1981 to that in 1987?
Keep it short and to the point. 0.04. What is the ratio of the Amount (in current US$) of International Development Association in 1981 to that in 1987?
Offer a very short reply. 11.43. What is the ratio of the Amount (in current US$) in Regional development banks in 1981 to that in 1988?
Keep it short and to the point. 0.13. What is the ratio of the Amount (in current US$) of International Development Association in 1981 to that in 1988?
Your answer should be compact. 534.77. What is the ratio of the Amount (in current US$) in Regional development banks in 1983 to that in 1984?
Keep it short and to the point. 0.83. What is the ratio of the Amount (in current US$) of International Development Association in 1983 to that in 1984?
Offer a terse response. 1.65. What is the ratio of the Amount (in current US$) in Others in 1983 to that in 1984?
Keep it short and to the point. 0.26. What is the ratio of the Amount (in current US$) in Regional development banks in 1983 to that in 1985?
Your answer should be compact. 0.8. What is the ratio of the Amount (in current US$) in International Development Association in 1983 to that in 1985?
Give a very brief answer. 2.2. What is the ratio of the Amount (in current US$) in Others in 1983 to that in 1985?
Your answer should be compact. 0.65. What is the ratio of the Amount (in current US$) in Regional development banks in 1983 to that in 1986?
Offer a terse response. 0.63. What is the ratio of the Amount (in current US$) of International Development Association in 1983 to that in 1986?
Give a very brief answer. 4.69. What is the ratio of the Amount (in current US$) in Others in 1983 to that in 1986?
Your answer should be very brief. 0.3. What is the ratio of the Amount (in current US$) of Regional development banks in 1983 to that in 1987?
Offer a very short reply. 0.89. What is the ratio of the Amount (in current US$) in International Development Association in 1983 to that in 1987?
Provide a succinct answer. 10.6. What is the ratio of the Amount (in current US$) in Regional development banks in 1983 to that in 1988?
Offer a terse response. 2.68. What is the ratio of the Amount (in current US$) of International Development Association in 1983 to that in 1988?
Your response must be concise. 495.69. What is the ratio of the Amount (in current US$) in Regional development banks in 1984 to that in 1985?
Offer a terse response. 0.97. What is the ratio of the Amount (in current US$) of International Development Association in 1984 to that in 1985?
Offer a very short reply. 1.33. What is the ratio of the Amount (in current US$) in Others in 1984 to that in 1985?
Make the answer very short. 2.51. What is the ratio of the Amount (in current US$) in Regional development banks in 1984 to that in 1986?
Your response must be concise. 0.76. What is the ratio of the Amount (in current US$) of International Development Association in 1984 to that in 1986?
Your answer should be compact. 2.84. What is the ratio of the Amount (in current US$) of Others in 1984 to that in 1986?
Provide a short and direct response. 1.15. What is the ratio of the Amount (in current US$) of Regional development banks in 1984 to that in 1987?
Offer a terse response. 1.08. What is the ratio of the Amount (in current US$) in International Development Association in 1984 to that in 1987?
Offer a terse response. 6.42. What is the ratio of the Amount (in current US$) in Regional development banks in 1984 to that in 1988?
Provide a short and direct response. 3.23. What is the ratio of the Amount (in current US$) of International Development Association in 1984 to that in 1988?
Give a very brief answer. 300.34. What is the ratio of the Amount (in current US$) in Regional development banks in 1985 to that in 1986?
Keep it short and to the point. 0.78. What is the ratio of the Amount (in current US$) in International Development Association in 1985 to that in 1986?
Your answer should be very brief. 2.13. What is the ratio of the Amount (in current US$) in Others in 1985 to that in 1986?
Give a very brief answer. 0.46. What is the ratio of the Amount (in current US$) of Regional development banks in 1985 to that in 1987?
Your answer should be compact. 1.12. What is the ratio of the Amount (in current US$) of International Development Association in 1985 to that in 1987?
Make the answer very short. 4.81. What is the ratio of the Amount (in current US$) of Regional development banks in 1985 to that in 1988?
Provide a succinct answer. 3.35. What is the ratio of the Amount (in current US$) in International Development Association in 1985 to that in 1988?
Offer a very short reply. 224.97. What is the ratio of the Amount (in current US$) of Regional development banks in 1986 to that in 1987?
Your answer should be compact. 1.43. What is the ratio of the Amount (in current US$) in International Development Association in 1986 to that in 1987?
Give a very brief answer. 2.26. What is the ratio of the Amount (in current US$) in Regional development banks in 1986 to that in 1988?
Offer a terse response. 4.28. What is the ratio of the Amount (in current US$) in International Development Association in 1986 to that in 1988?
Your response must be concise. 105.63. What is the ratio of the Amount (in current US$) in Regional development banks in 1987 to that in 1988?
Your response must be concise. 2.99. What is the ratio of the Amount (in current US$) of International Development Association in 1987 to that in 1988?
Make the answer very short. 46.77. What is the difference between the highest and the second highest Amount (in current US$) in Regional development banks?
Give a very brief answer. 2.52e+06. What is the difference between the highest and the second highest Amount (in current US$) in International Monetary Fund?
Your answer should be very brief. 7.81e+06. What is the difference between the highest and the second highest Amount (in current US$) in International Development Association?
Your response must be concise. 1.37e+06. What is the difference between the highest and the second highest Amount (in current US$) of Others?
Keep it short and to the point. 3.02e+06. What is the difference between the highest and the lowest Amount (in current US$) in Regional development banks?
Your response must be concise. 1.13e+07. What is the difference between the highest and the lowest Amount (in current US$) of International Monetary Fund?
Your answer should be very brief. 5.25e+07. What is the difference between the highest and the lowest Amount (in current US$) of International Development Association?
Offer a terse response. 1.87e+07. What is the difference between the highest and the lowest Amount (in current US$) in Others?
Ensure brevity in your answer.  2.25e+07. 